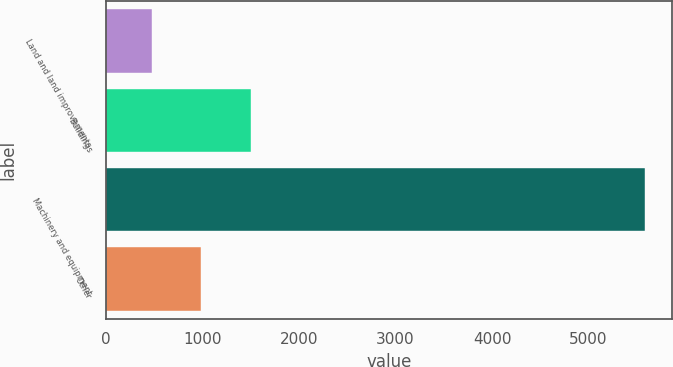Convert chart to OTSL. <chart><loc_0><loc_0><loc_500><loc_500><bar_chart><fcel>Land and land improvements<fcel>Buildings<fcel>Machinery and equipment<fcel>Other<nl><fcel>477<fcel>1499<fcel>5587<fcel>988<nl></chart> 